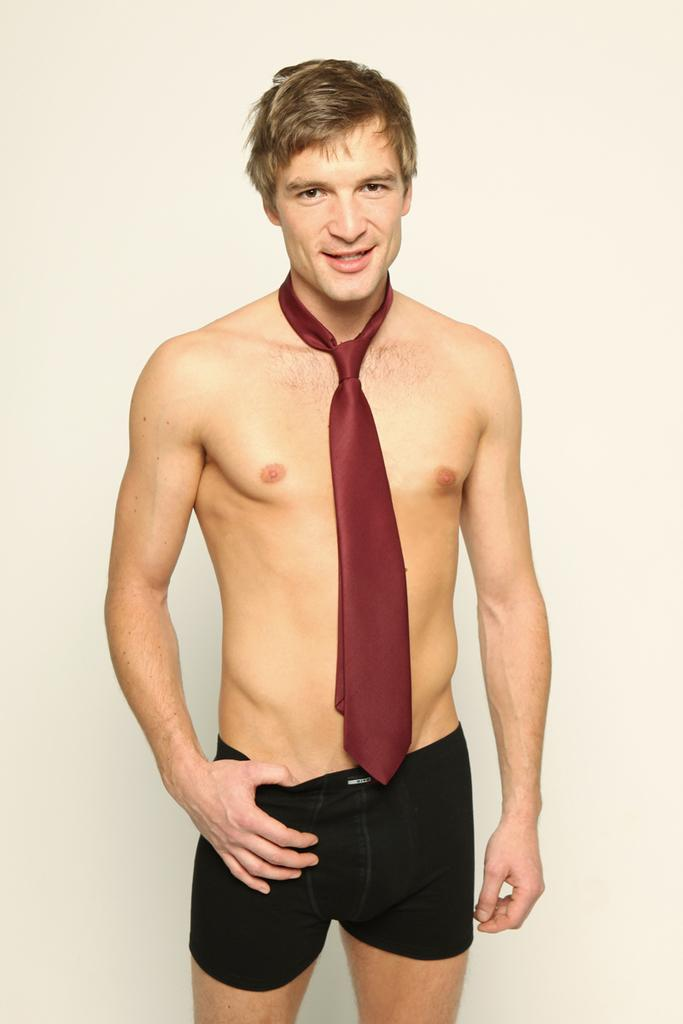Who or what is the main subject of the image? There is a person in the image. What is the person wearing around their neck? The person is wearing a maroon color tie. What is the person doing in the image? The person is standing and smiling. What color is the background of the image? There is a cream color background in the image. What condition is the grandmother's sink in the image? There is no grandmother or sink present in the image. 